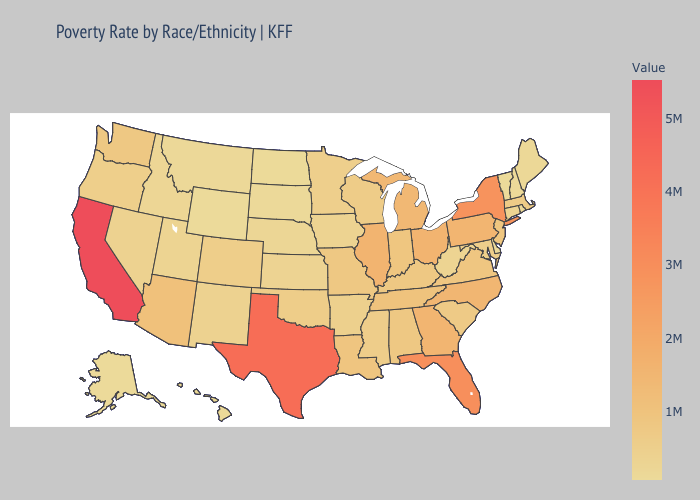Does Michigan have the highest value in the USA?
Short answer required. No. Does Colorado have a higher value than Georgia?
Short answer required. No. Which states have the lowest value in the Northeast?
Answer briefly. Vermont. Among the states that border Mississippi , does Arkansas have the lowest value?
Keep it brief. Yes. Which states have the lowest value in the MidWest?
Keep it brief. North Dakota. 